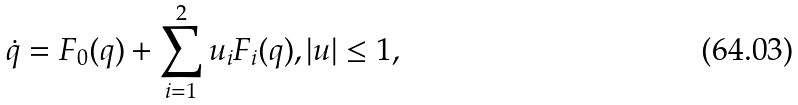<formula> <loc_0><loc_0><loc_500><loc_500>\dot { q } = F _ { 0 } ( q ) + \sum _ { i = 1 } ^ { 2 } u _ { i } F _ { i } ( q ) , | u | \leq 1 ,</formula> 